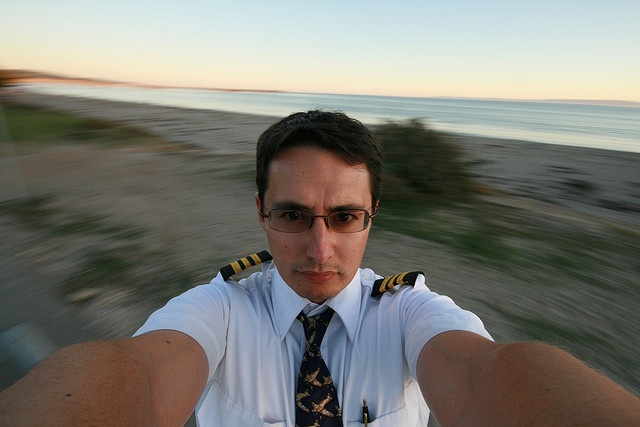Describe the objects in this image and their specific colors. I can see people in lightgray, maroon, darkgray, gray, and black tones and tie in lightgray, black, gray, and maroon tones in this image. 